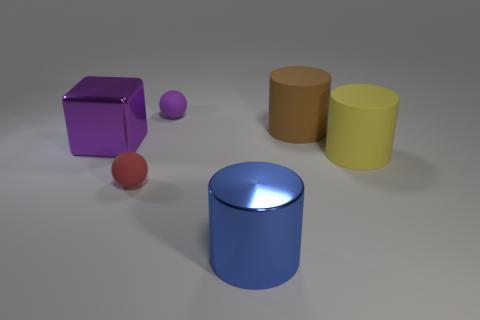What size is the purple shiny object?
Give a very brief answer. Large. There is a yellow rubber object; does it have the same size as the rubber thing that is in front of the big yellow matte cylinder?
Provide a succinct answer. No. There is a metallic thing that is on the left side of the metal object on the right side of the metallic object behind the metallic cylinder; what color is it?
Offer a very short reply. Purple. Do the tiny sphere that is behind the big shiny cube and the big brown thing have the same material?
Offer a very short reply. Yes. What number of other objects are there of the same material as the red thing?
Offer a terse response. 3. There is a blue cylinder that is the same size as the yellow matte cylinder; what is its material?
Your answer should be compact. Metal. Does the small rubber object behind the brown matte cylinder have the same shape as the large metal thing to the left of the tiny red sphere?
Give a very brief answer. No. What is the shape of the blue metallic thing that is the same size as the brown matte object?
Provide a succinct answer. Cylinder. Are the large object on the left side of the big blue cylinder and the cylinder that is in front of the big yellow rubber cylinder made of the same material?
Ensure brevity in your answer.  Yes. Are there any tiny purple matte balls behind the big blue metallic cylinder that is to the left of the yellow rubber object?
Offer a terse response. Yes. 